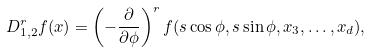Convert formula to latex. <formula><loc_0><loc_0><loc_500><loc_500>D _ { 1 , 2 } ^ { r } f ( x ) = \left ( - \frac { \partial } { \partial \phi } \right ) ^ { r } f ( s \cos \phi , s \sin \phi , x _ { 3 } , \dots , x _ { d } ) ,</formula> 